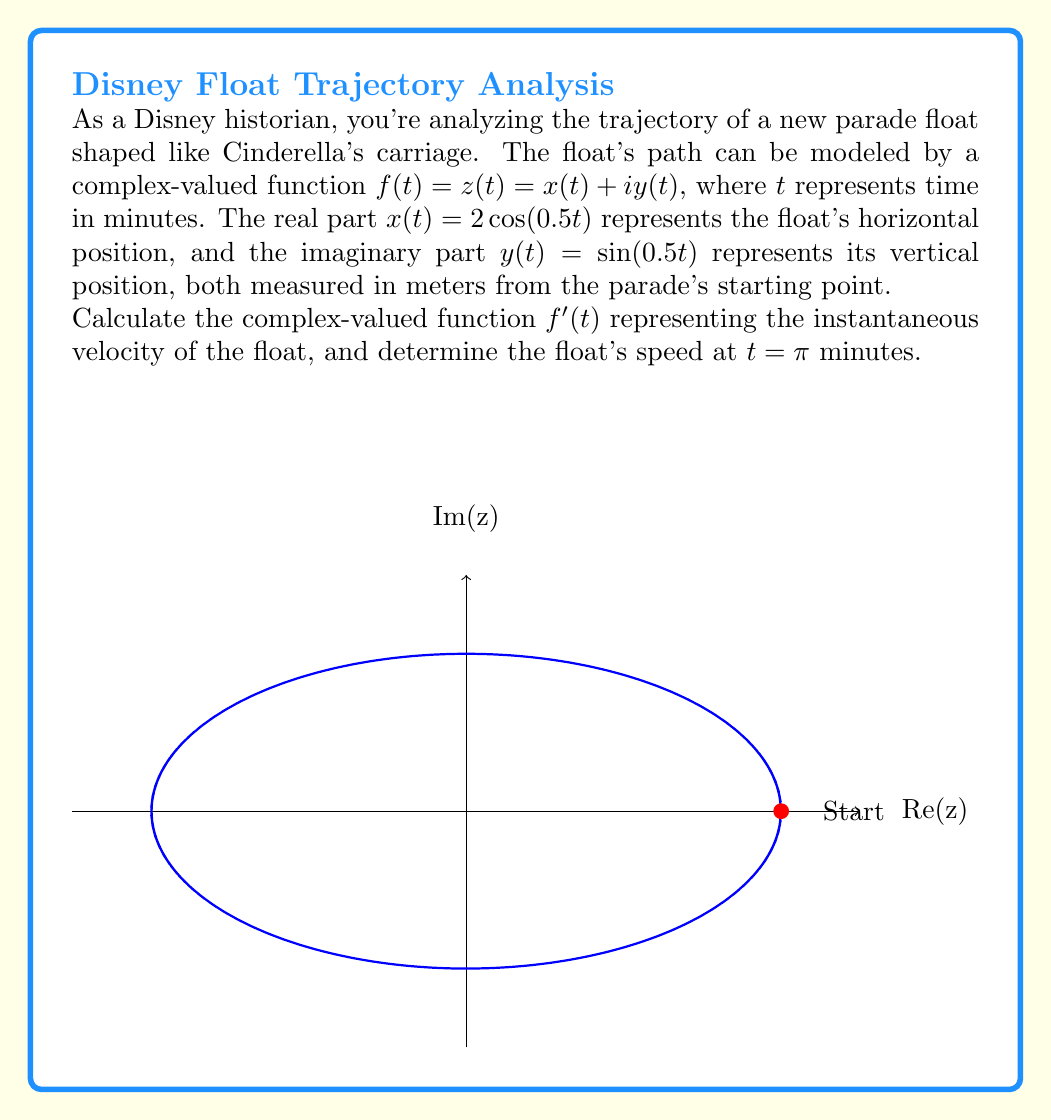What is the answer to this math problem? Let's approach this step-by-step:

1) The given complex-valued function is:
   $$f(t) = z(t) = x(t) + iy(t) = 2\cos(0.5t) + i\sin(0.5t)$$

2) To find the instantaneous velocity, we need to differentiate $f(t)$ with respect to $t$:
   $$f'(t) = \frac{d}{dt}[2\cos(0.5t)] + i\frac{d}{dt}[\sin(0.5t)]$$

3) Using the chain rule:
   $$f'(t) = 2 \cdot (-0.5\sin(0.5t)) + i \cdot (0.5\cos(0.5t))$$
   $$f'(t) = -\sin(0.5t) + 0.5i\cos(0.5t)$$

4) This $f'(t)$ represents the instantaneous velocity of the float.

5) To find the speed at $t = \pi$ minutes, we need to calculate the magnitude of $f'(\pi)$:
   $$f'(\pi) = -\sin(0.5\pi) + 0.5i\cos(0.5\pi) = -1 + 0i = -1$$

6) The speed is the absolute value of this complex number:
   $$\text{Speed} = |f'(\pi)| = |-1| = 1$$

Thus, the float's speed at $t = \pi$ minutes is 1 meter per minute.
Answer: $f'(t) = -\sin(0.5t) + 0.5i\cos(0.5t)$; Speed at $t = \pi$: 1 m/min 